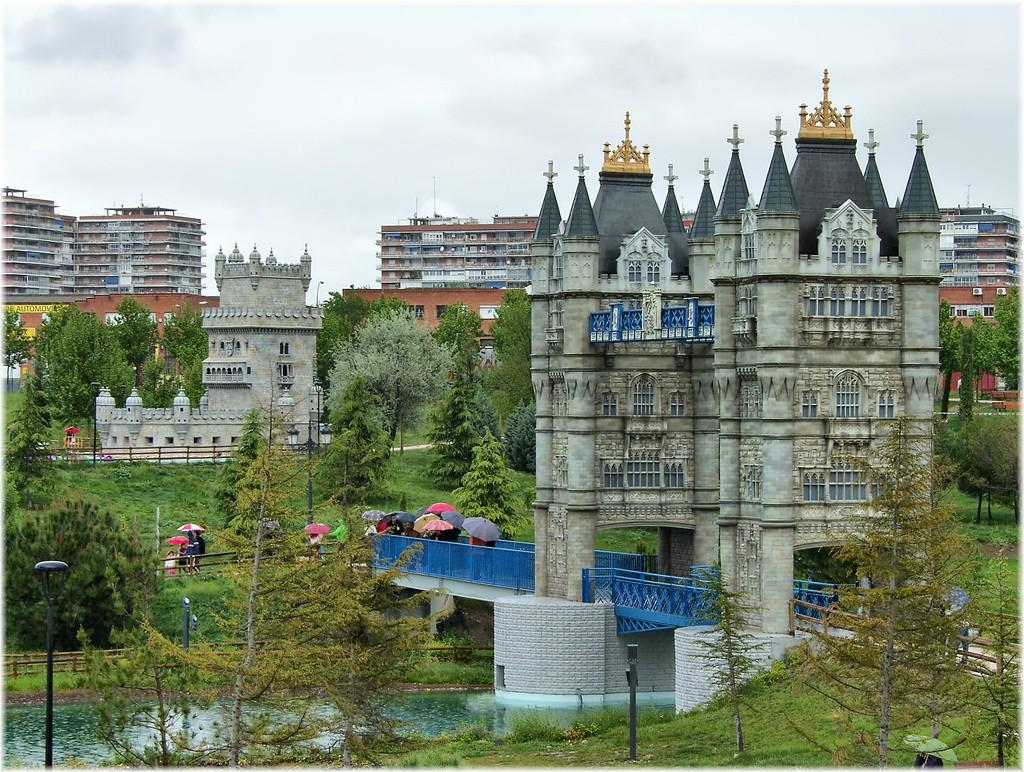What structure can be seen in the image? There is a bridge in the image. What is under the bridge? Water is visible under the bridge. Who or what can be seen in the image? There are people in the image. What objects are being used by the people in the image? Umbrellas are present in the image. What can be seen in the background of the image? There are buildings, trees, and the sky visible in the background of the image. What type of brass instrument can be heard playing in the image? There is no brass instrument or sound present in the image; it is a visual representation of a bridge, water, people, and umbrellas. 